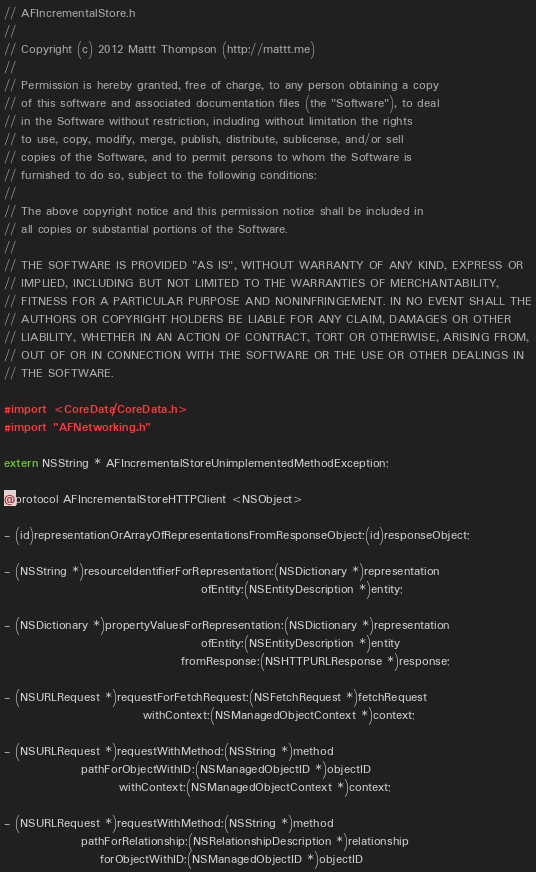<code> <loc_0><loc_0><loc_500><loc_500><_C_>// AFIncrementalStore.h
//
// Copyright (c) 2012 Mattt Thompson (http://mattt.me)
// 
// Permission is hereby granted, free of charge, to any person obtaining a copy
// of this software and associated documentation files (the "Software"), to deal
// in the Software without restriction, including without limitation the rights
// to use, copy, modify, merge, publish, distribute, sublicense, and/or sell
// copies of the Software, and to permit persons to whom the Software is
// furnished to do so, subject to the following conditions:
// 
// The above copyright notice and this permission notice shall be included in
// all copies or substantial portions of the Software.
// 
// THE SOFTWARE IS PROVIDED "AS IS", WITHOUT WARRANTY OF ANY KIND, EXPRESS OR
// IMPLIED, INCLUDING BUT NOT LIMITED TO THE WARRANTIES OF MERCHANTABILITY,
// FITNESS FOR A PARTICULAR PURPOSE AND NONINFRINGEMENT. IN NO EVENT SHALL THE
// AUTHORS OR COPYRIGHT HOLDERS BE LIABLE FOR ANY CLAIM, DAMAGES OR OTHER
// LIABILITY, WHETHER IN AN ACTION OF CONTRACT, TORT OR OTHERWISE, ARISING FROM,
// OUT OF OR IN CONNECTION WITH THE SOFTWARE OR THE USE OR OTHER DEALINGS IN
// THE SOFTWARE.

#import <CoreData/CoreData.h>
#import "AFNetworking.h"

extern NSString * AFIncrementalStoreUnimplementedMethodException;

@protocol AFIncrementalStoreHTTPClient <NSObject>

- (id)representationOrArrayOfRepresentationsFromResponseObject:(id)responseObject;

- (NSString *)resourceIdentifierForRepresentation:(NSDictionary *)representation
                                         ofEntity:(NSEntityDescription *)entity;

- (NSDictionary *)propertyValuesForRepresentation:(NSDictionary *)representation
                                         ofEntity:(NSEntityDescription *)entity
                                     fromResponse:(NSHTTPURLResponse *)response;

- (NSURLRequest *)requestForFetchRequest:(NSFetchRequest *)fetchRequest
                             withContext:(NSManagedObjectContext *)context;

- (NSURLRequest *)requestWithMethod:(NSString *)method
                pathForObjectWithID:(NSManagedObjectID *)objectID
                        withContext:(NSManagedObjectContext *)context;

- (NSURLRequest *)requestWithMethod:(NSString *)method
                pathForRelationship:(NSRelationshipDescription *)relationship
                    forObjectWithID:(NSManagedObjectID *)objectID</code> 